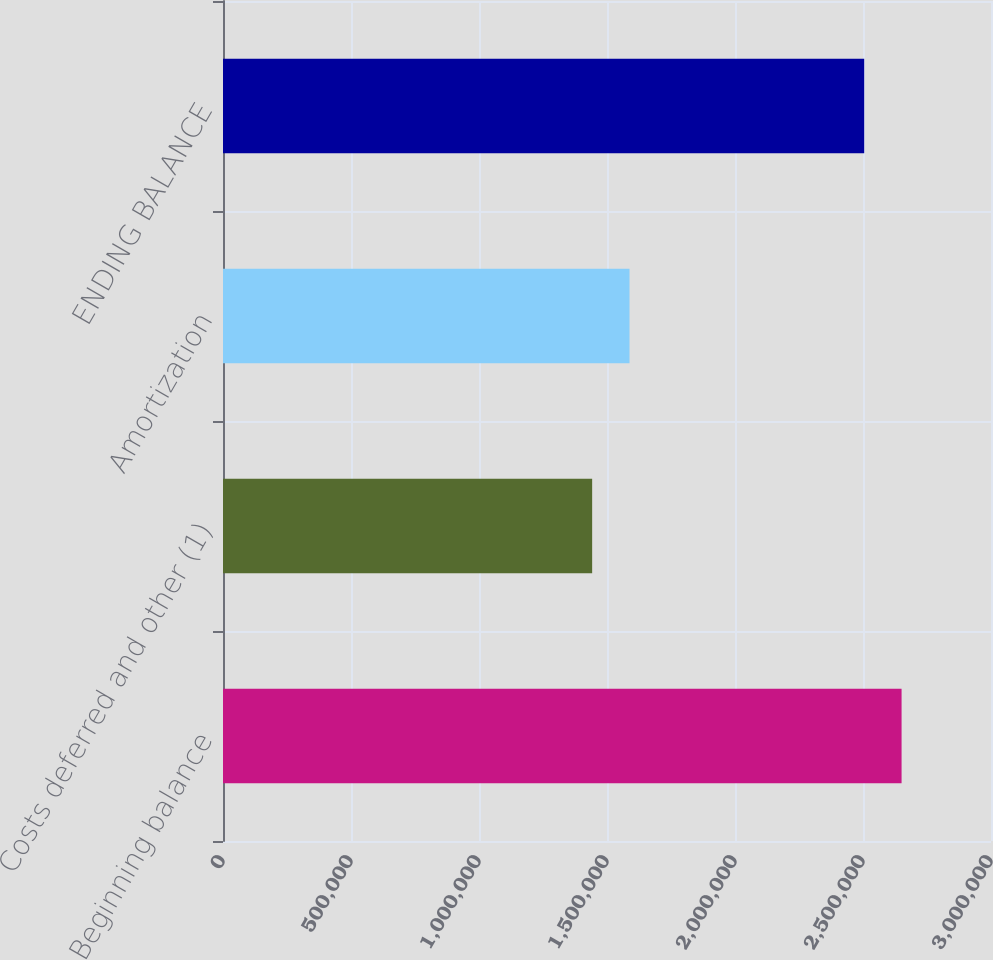Convert chart to OTSL. <chart><loc_0><loc_0><loc_500><loc_500><bar_chart><fcel>Beginning balance<fcel>Costs deferred and other (1)<fcel>Amortization<fcel>ENDING BALANCE<nl><fcel>2.65067e+06<fcel>1.44197e+06<fcel>1.58799e+06<fcel>2.50465e+06<nl></chart> 